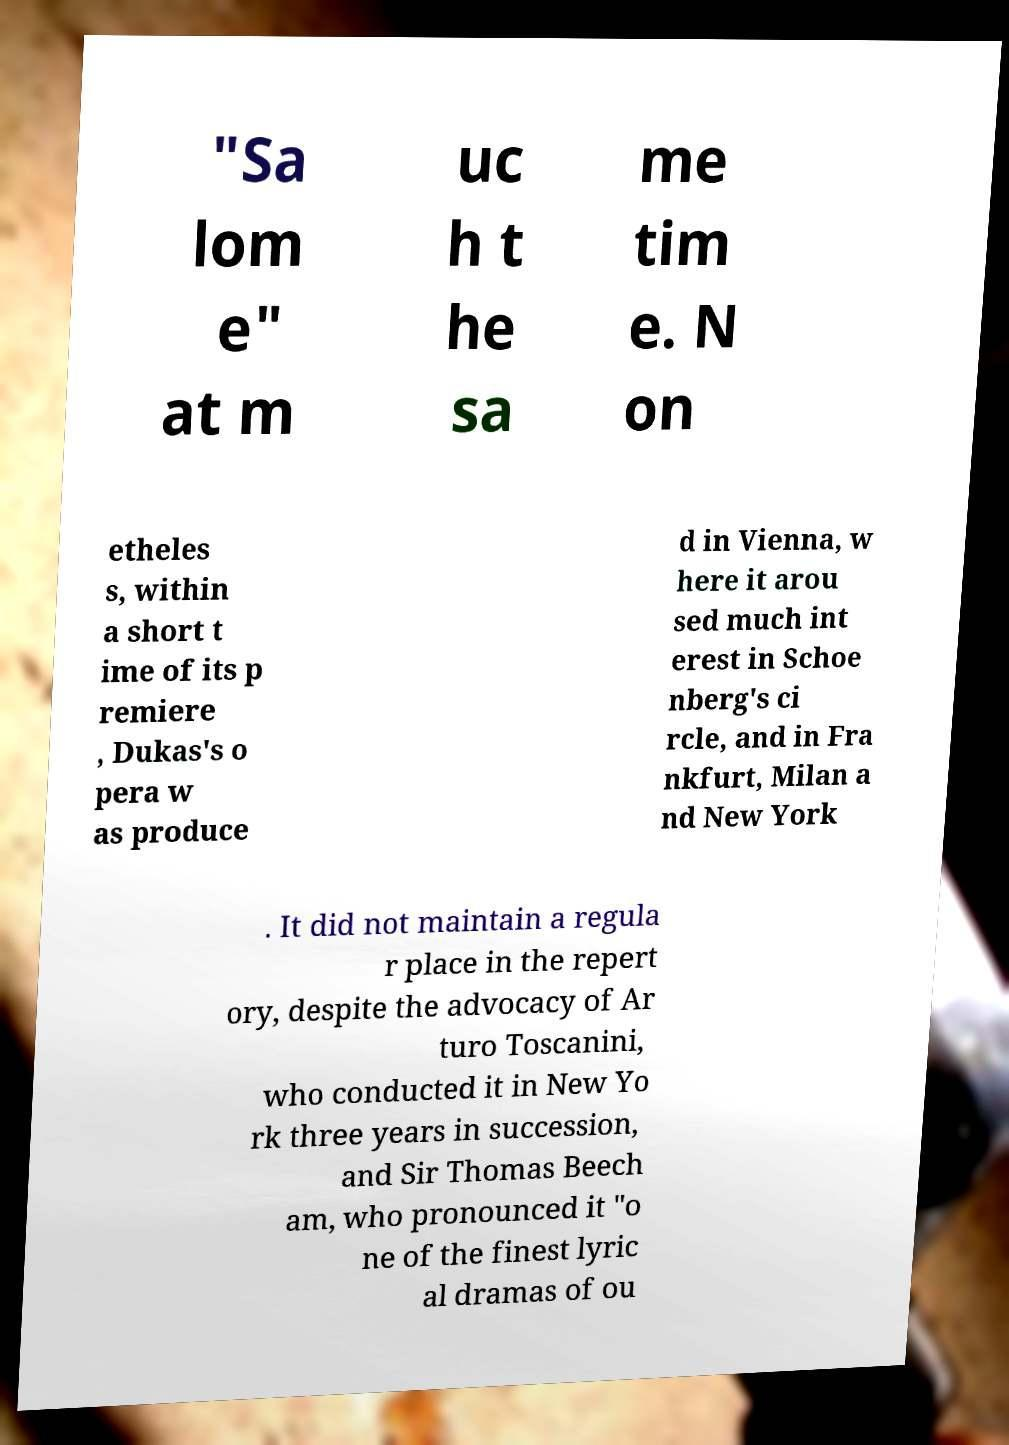Could you assist in decoding the text presented in this image and type it out clearly? "Sa lom e" at m uc h t he sa me tim e. N on etheles s, within a short t ime of its p remiere , Dukas's o pera w as produce d in Vienna, w here it arou sed much int erest in Schoe nberg's ci rcle, and in Fra nkfurt, Milan a nd New York . It did not maintain a regula r place in the repert ory, despite the advocacy of Ar turo Toscanini, who conducted it in New Yo rk three years in succession, and Sir Thomas Beech am, who pronounced it "o ne of the finest lyric al dramas of ou 